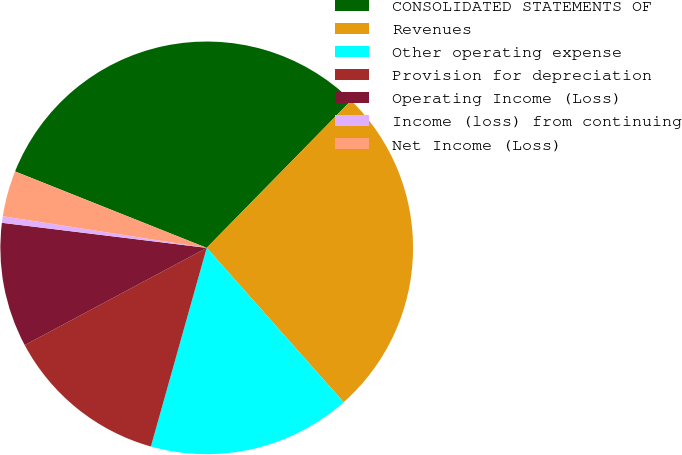<chart> <loc_0><loc_0><loc_500><loc_500><pie_chart><fcel>CONSOLIDATED STATEMENTS OF<fcel>Revenues<fcel>Other operating expense<fcel>Provision for depreciation<fcel>Operating Income (Loss)<fcel>Income (loss) from continuing<fcel>Net Income (Loss)<nl><fcel>31.3%<fcel>26.11%<fcel>15.91%<fcel>12.83%<fcel>9.75%<fcel>0.51%<fcel>3.59%<nl></chart> 